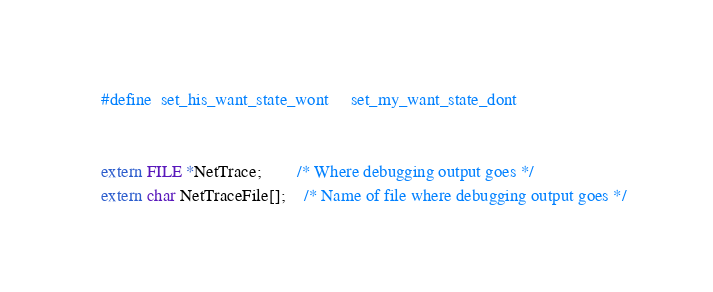<code> <loc_0><loc_0><loc_500><loc_500><_C_>#define	set_his_want_state_wont		set_my_want_state_dont


extern FILE *NetTrace;		/* Where debugging output goes */
extern char NetTraceFile[];	/* Name of file where debugging output goes */
</code> 